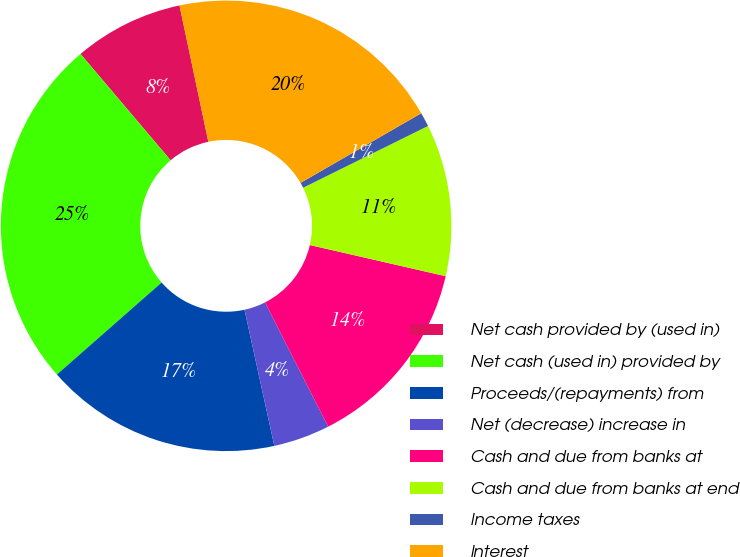Convert chart. <chart><loc_0><loc_0><loc_500><loc_500><pie_chart><fcel>Net cash provided by (used in)<fcel>Net cash (used in) provided by<fcel>Proceeds/(repayments) from<fcel>Net (decrease) increase in<fcel>Cash and due from banks at<fcel>Cash and due from banks at end<fcel>Income taxes<fcel>Interest<nl><fcel>7.87%<fcel>25.29%<fcel>16.96%<fcel>4.05%<fcel>13.93%<fcel>10.9%<fcel>1.02%<fcel>19.99%<nl></chart> 